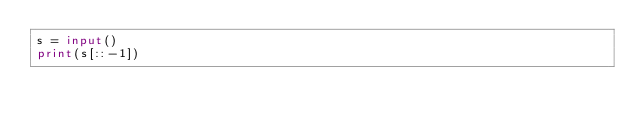Convert code to text. <code><loc_0><loc_0><loc_500><loc_500><_Python_>s = input()
print(s[::-1])</code> 